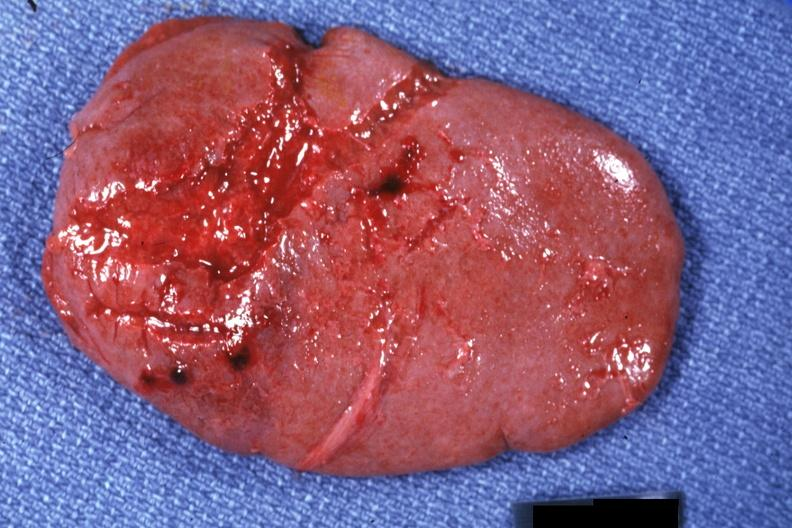what is present?
Answer the question using a single word or phrase. Traumatic rupture 